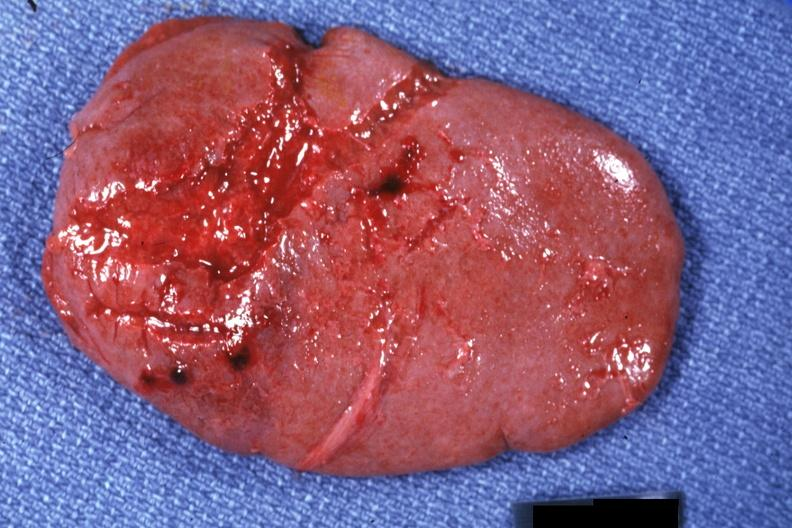what is present?
Answer the question using a single word or phrase. Traumatic rupture 